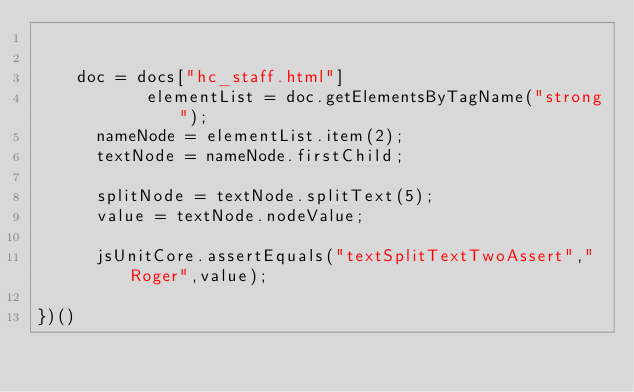Convert code to text. <code><loc_0><loc_0><loc_500><loc_500><_JavaScript_>	   
	   
	doc = docs["hc_staff.html"]
           elementList = doc.getElementsByTagName("strong");
      nameNode = elementList.item(2);
      textNode = nameNode.firstChild;

      splitNode = textNode.splitText(5);
      value = textNode.nodeValue;

      jsUnitCore.assertEquals("textSplitTextTwoAssert","Roger",value);
       
})()

</code> 